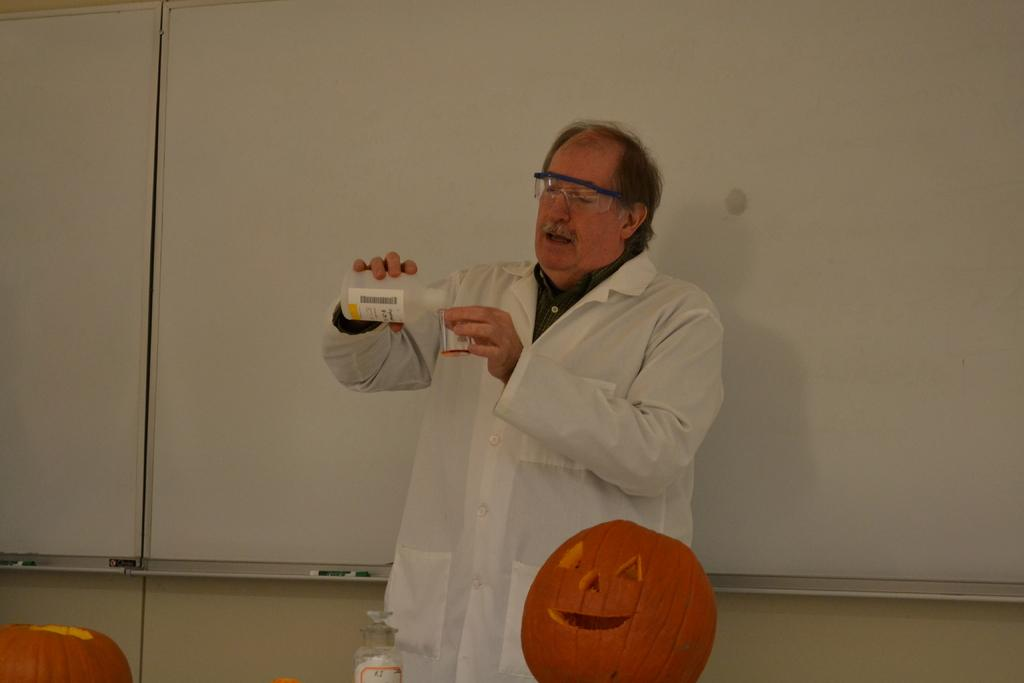Who is the main subject in the image? There is an old man in the image. What is the old man wearing? The old man is wearing a white apron and glasses. What is the old man doing in the image? The old man is showing a chemistry experiment to someone. What type of snake can be seen slithering across the chemistry experiment in the image? There is no snake present in the image; it features an old man showing a chemistry experiment. How many planes are visible in the image? There are no planes visible in the image. 